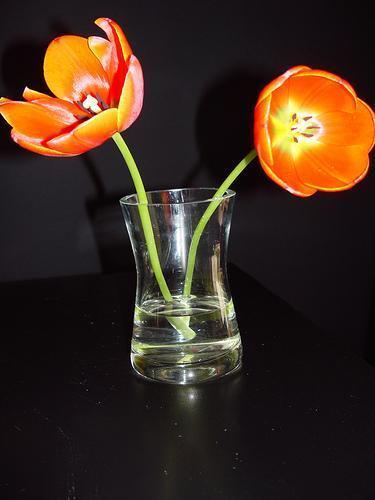How many flowers are there?
Give a very brief answer. 2. 